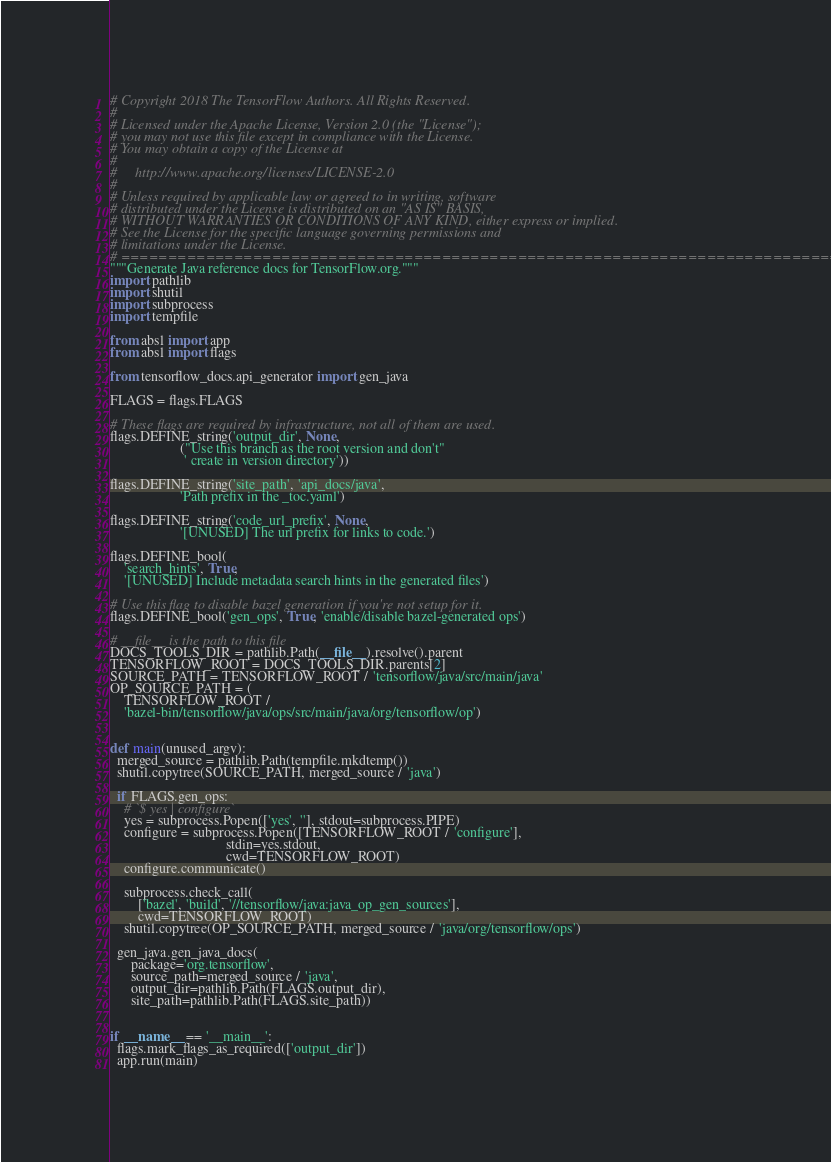Convert code to text. <code><loc_0><loc_0><loc_500><loc_500><_Python_># Copyright 2018 The TensorFlow Authors. All Rights Reserved.
#
# Licensed under the Apache License, Version 2.0 (the "License");
# you may not use this file except in compliance with the License.
# You may obtain a copy of the License at
#
#     http://www.apache.org/licenses/LICENSE-2.0
#
# Unless required by applicable law or agreed to in writing, software
# distributed under the License is distributed on an "AS IS" BASIS,
# WITHOUT WARRANTIES OR CONDITIONS OF ANY KIND, either express or implied.
# See the License for the specific language governing permissions and
# limitations under the License.
# ==============================================================================
"""Generate Java reference docs for TensorFlow.org."""
import pathlib
import shutil
import subprocess
import tempfile

from absl import app
from absl import flags

from tensorflow_docs.api_generator import gen_java

FLAGS = flags.FLAGS

# These flags are required by infrastructure, not all of them are used.
flags.DEFINE_string('output_dir', None,
                    ("Use this branch as the root version and don't"
                     ' create in version directory'))

flags.DEFINE_string('site_path', 'api_docs/java',
                    'Path prefix in the _toc.yaml')

flags.DEFINE_string('code_url_prefix', None,
                    '[UNUSED] The url prefix for links to code.')

flags.DEFINE_bool(
    'search_hints', True,
    '[UNUSED] Include metadata search hints in the generated files')

# Use this flag to disable bazel generation if you're not setup for it.
flags.DEFINE_bool('gen_ops', True, 'enable/disable bazel-generated ops')

# __file__ is the path to this file
DOCS_TOOLS_DIR = pathlib.Path(__file__).resolve().parent
TENSORFLOW_ROOT = DOCS_TOOLS_DIR.parents[2]
SOURCE_PATH = TENSORFLOW_ROOT / 'tensorflow/java/src/main/java'
OP_SOURCE_PATH = (
    TENSORFLOW_ROOT /
    'bazel-bin/tensorflow/java/ops/src/main/java/org/tensorflow/op')


def main(unused_argv):
  merged_source = pathlib.Path(tempfile.mkdtemp())
  shutil.copytree(SOURCE_PATH, merged_source / 'java')

  if FLAGS.gen_ops:
    # `$ yes | configure`
    yes = subprocess.Popen(['yes', ''], stdout=subprocess.PIPE)
    configure = subprocess.Popen([TENSORFLOW_ROOT / 'configure'],
                                 stdin=yes.stdout,
                                 cwd=TENSORFLOW_ROOT)
    configure.communicate()

    subprocess.check_call(
        ['bazel', 'build', '//tensorflow/java:java_op_gen_sources'],
        cwd=TENSORFLOW_ROOT)
    shutil.copytree(OP_SOURCE_PATH, merged_source / 'java/org/tensorflow/ops')

  gen_java.gen_java_docs(
      package='org.tensorflow',
      source_path=merged_source / 'java',
      output_dir=pathlib.Path(FLAGS.output_dir),
      site_path=pathlib.Path(FLAGS.site_path))


if __name__ == '__main__':
  flags.mark_flags_as_required(['output_dir'])
  app.run(main)
</code> 